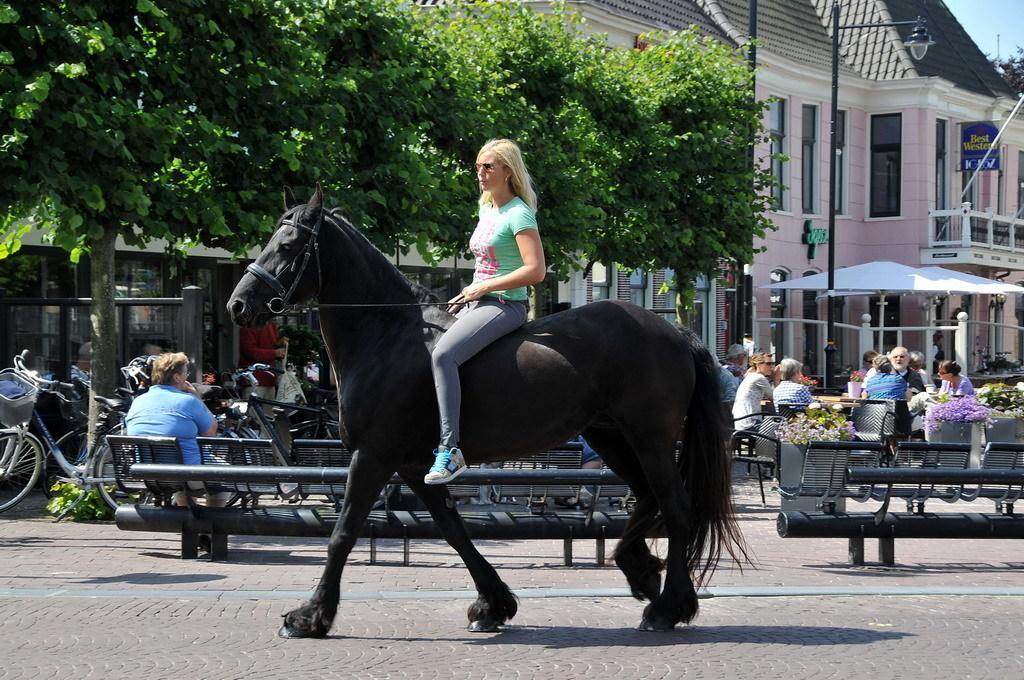What is the person in the image riding? The person is riding a black horse, a black horse. What objects are behind the person? There are chairs behind the person. What type of vehicles are on the right side? There are bicycles on the right side of the image. What can be seen in the background of the image? There are trees and a building in the background. Where is the sink located in the image? There is no sink present in the image. What type of gate can be seen in the image? There is no gate present in the image. 